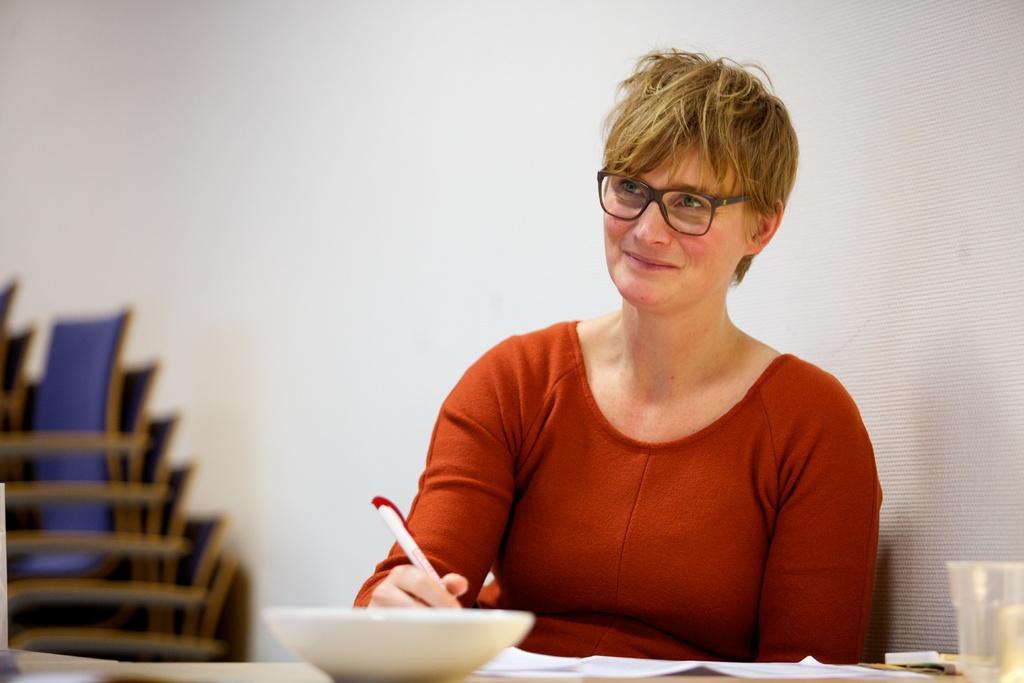Describe this image in one or two sentences. In this picture we can see a woman, she wore spectacles and she is holding a pen, in front of her we can see a bowl, glass and a paper on the table, on the left side of the image we can find few chairs. 